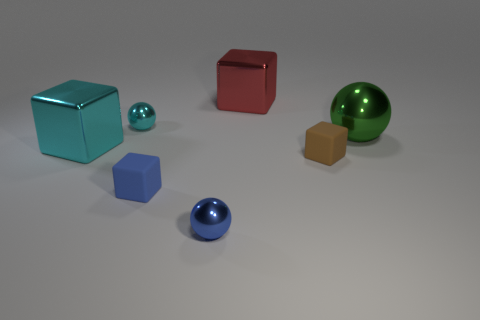There is a blue object that is the same shape as the green object; what is it made of?
Give a very brief answer. Metal. There is a block that is both behind the brown rubber block and left of the red metal cube; how big is it?
Offer a very short reply. Large. What is the shape of the large cyan shiny object?
Your answer should be very brief. Cube. How many objects are either big green things or balls to the left of the large red metallic cube?
Your response must be concise. 3. There is a block that is behind the large ball; is its color the same as the big ball?
Provide a succinct answer. No. What is the color of the sphere that is behind the tiny brown rubber thing and on the left side of the big green sphere?
Offer a very short reply. Cyan. What material is the green thing in front of the small cyan ball?
Offer a very short reply. Metal. The cyan cube is what size?
Make the answer very short. Large. What number of blue things are either metal blocks or small spheres?
Offer a very short reply. 1. What size is the cyan metallic thing that is on the right side of the cyan object that is on the left side of the tiny cyan sphere?
Provide a succinct answer. Small. 